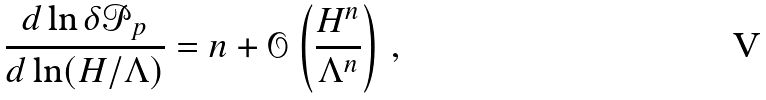<formula> <loc_0><loc_0><loc_500><loc_500>\frac { d \ln \delta \mathcal { P } _ { p } } { d \ln ( H / \Lambda ) } = n + \mathcal { O } \left ( \frac { H ^ { n } } { \Lambda ^ { n } } \right ) \, ,</formula> 